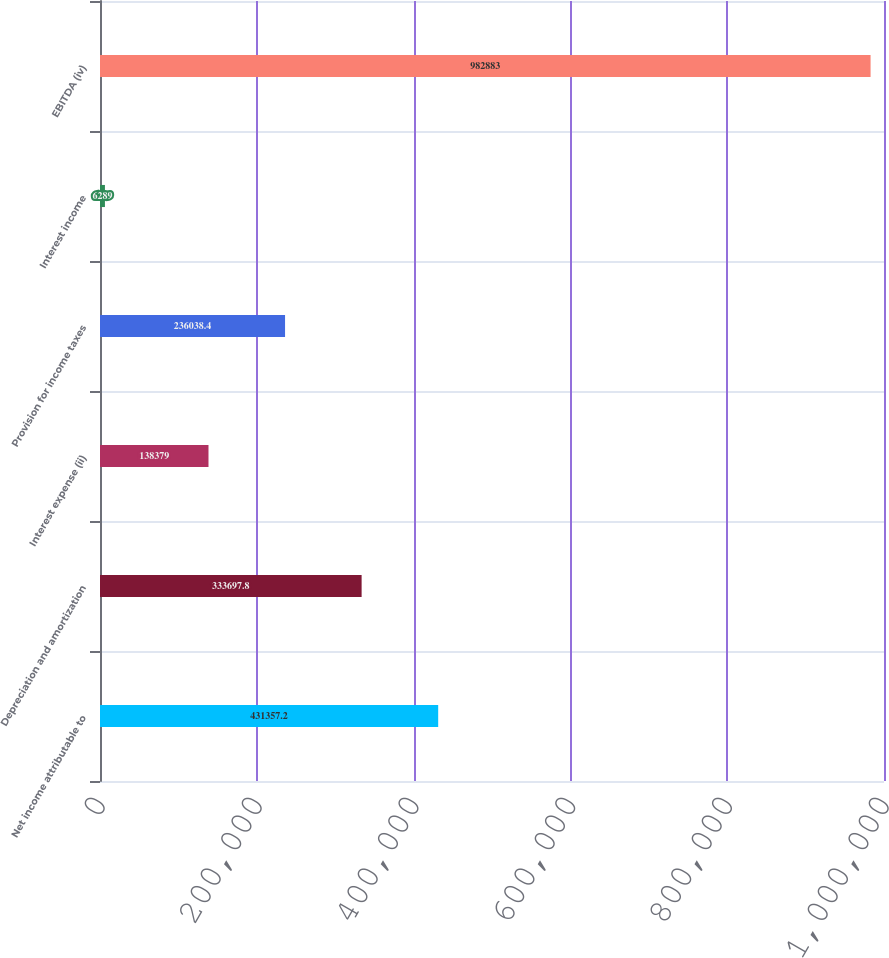Convert chart to OTSL. <chart><loc_0><loc_0><loc_500><loc_500><bar_chart><fcel>Net income attributable to<fcel>Depreciation and amortization<fcel>Interest expense (ii)<fcel>Provision for income taxes<fcel>Interest income<fcel>EBITDA (iv)<nl><fcel>431357<fcel>333698<fcel>138379<fcel>236038<fcel>6289<fcel>982883<nl></chart> 